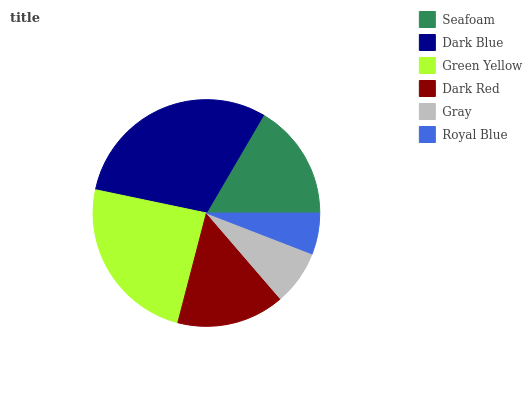Is Royal Blue the minimum?
Answer yes or no. Yes. Is Dark Blue the maximum?
Answer yes or no. Yes. Is Green Yellow the minimum?
Answer yes or no. No. Is Green Yellow the maximum?
Answer yes or no. No. Is Dark Blue greater than Green Yellow?
Answer yes or no. Yes. Is Green Yellow less than Dark Blue?
Answer yes or no. Yes. Is Green Yellow greater than Dark Blue?
Answer yes or no. No. Is Dark Blue less than Green Yellow?
Answer yes or no. No. Is Seafoam the high median?
Answer yes or no. Yes. Is Dark Red the low median?
Answer yes or no. Yes. Is Royal Blue the high median?
Answer yes or no. No. Is Gray the low median?
Answer yes or no. No. 